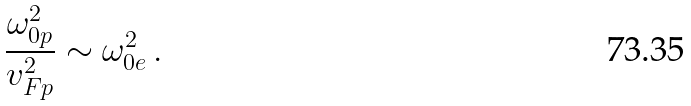<formula> <loc_0><loc_0><loc_500><loc_500>\frac { \omega _ { 0 p } ^ { 2 } } { v _ { F p } ^ { 2 } } \sim \omega _ { 0 e } ^ { 2 } \, .</formula> 